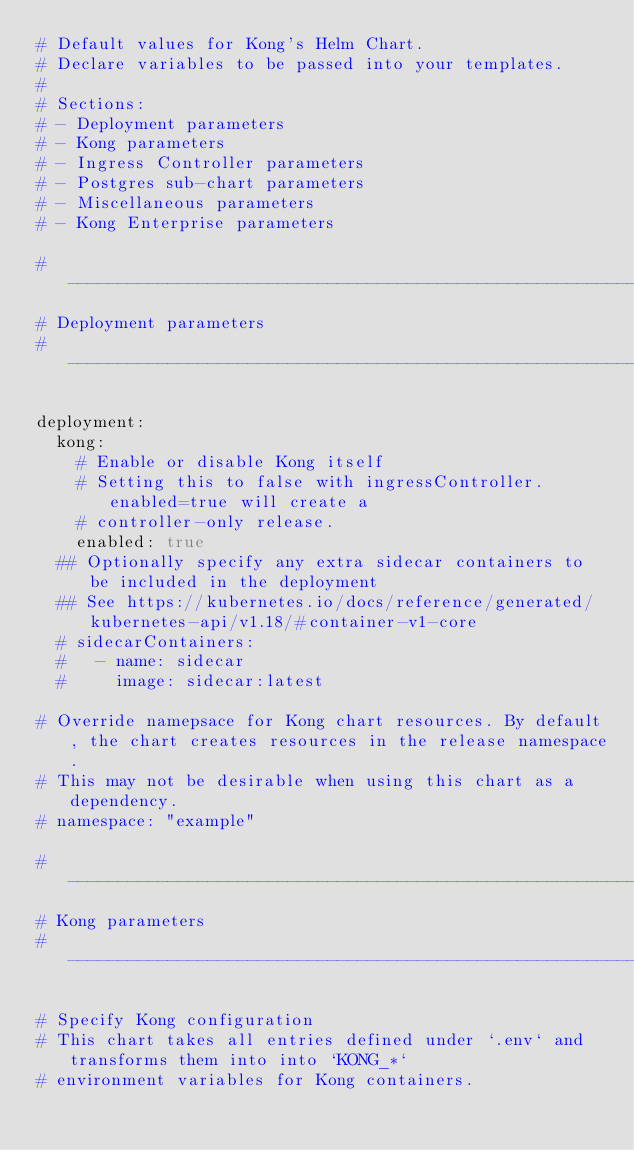Convert code to text. <code><loc_0><loc_0><loc_500><loc_500><_YAML_># Default values for Kong's Helm Chart.
# Declare variables to be passed into your templates.
#
# Sections:
# - Deployment parameters
# - Kong parameters
# - Ingress Controller parameters
# - Postgres sub-chart parameters
# - Miscellaneous parameters
# - Kong Enterprise parameters

# -----------------------------------------------------------------------------
# Deployment parameters
# -----------------------------------------------------------------------------

deployment:
  kong:
    # Enable or disable Kong itself
    # Setting this to false with ingressController.enabled=true will create a
    # controller-only release.
    enabled: true
  ## Optionally specify any extra sidecar containers to be included in the deployment
  ## See https://kubernetes.io/docs/reference/generated/kubernetes-api/v1.18/#container-v1-core
  # sidecarContainers:
  #   - name: sidecar
  #     image: sidecar:latest

# Override namepsace for Kong chart resources. By default, the chart creates resources in the release namespace.
# This may not be desirable when using this chart as a dependency.
# namespace: "example"

# -----------------------------------------------------------------------------
# Kong parameters
# -----------------------------------------------------------------------------

# Specify Kong configuration
# This chart takes all entries defined under `.env` and transforms them into into `KONG_*`
# environment variables for Kong containers.</code> 